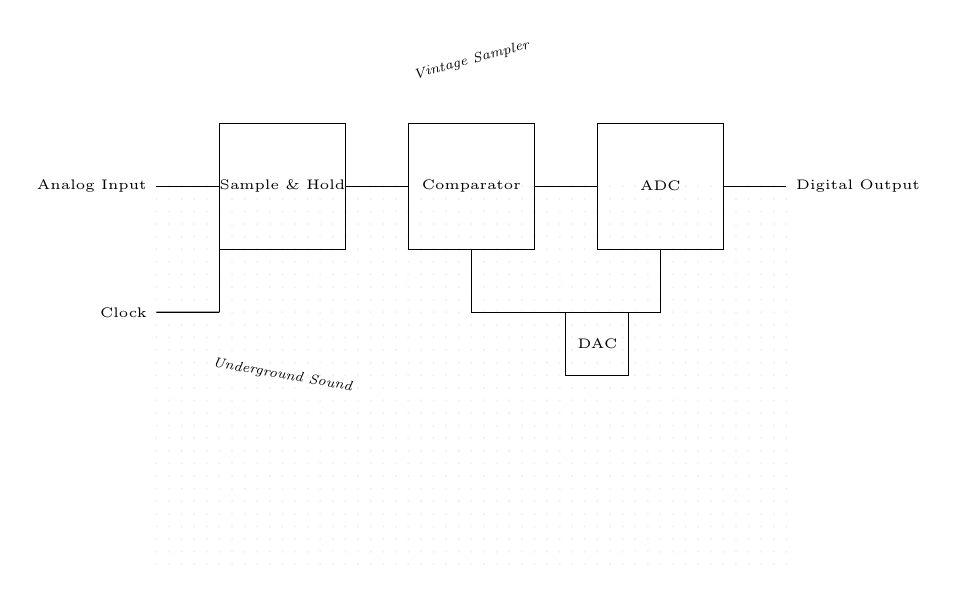What is the function of the "Sample & Hold" component? The Sample & Hold component captures the analog input voltage at a specific moment and holds that value for processing by the comparator. This allows the ADC to operate on stable signals rather than continuously varying inputs.
Answer: Sample & Hold How many components are shown in this circuit diagram? To find the total number of components, we count the visible elements: 1 Sample & Hold, 1 Comparator, 1 ADC, 1 DAC, and connections. Thus, there are 5 primary components in view.
Answer: 5 What type of output is generated by the ADC? The ADC (Analog to Digital Converter) transforms the analog voltage level into a digital signal, which usually consists of binary values representing the amplitude of the input voltage at the time of sampling.
Answer: Digital What connects the Sample & Hold to the Comparator? The Sample & Hold is connected directly to the Comparator via a line that represents a signal path, indicating that the stable voltage output from the Sample & Hold is sent as input to the Comparator for further processing.
Answer: Direct connection What role does the DAC play in this circuit? The DAC (Digital to Analog Converter) takes digital output from the ADC and converts it back into an analog signal. This feedback allows for adjustments and accurate representation of the original input after digitization.
Answer: Feedback conversion What is the purpose of the Clock in this circuit? The Clock provides timing signals for synchronization in the circuit. This ensures that the sampling, holding, and conversion processes occur at precise intervals, maintaining the integrity and timing of the sampled data.
Answer: Synchronization 